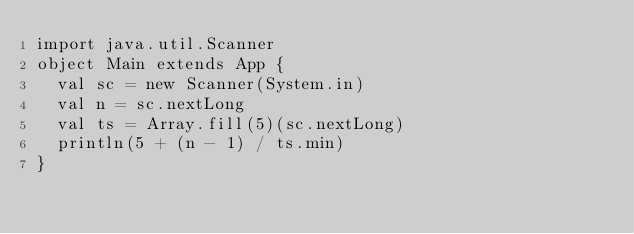<code> <loc_0><loc_0><loc_500><loc_500><_Scala_>import java.util.Scanner
object Main extends App {
  val sc = new Scanner(System.in)
  val n = sc.nextLong
  val ts = Array.fill(5)(sc.nextLong)
  println(5 + (n - 1) / ts.min)
}</code> 